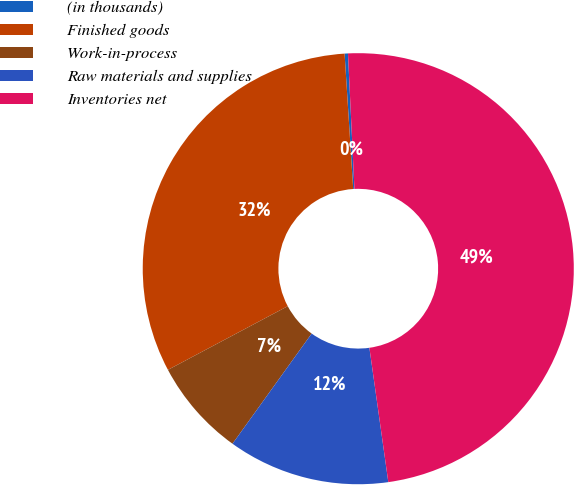Convert chart. <chart><loc_0><loc_0><loc_500><loc_500><pie_chart><fcel>(in thousands)<fcel>Finished goods<fcel>Work-in-process<fcel>Raw materials and supplies<fcel>Inventories net<nl><fcel>0.25%<fcel>31.76%<fcel>7.31%<fcel>12.14%<fcel>48.53%<nl></chart> 